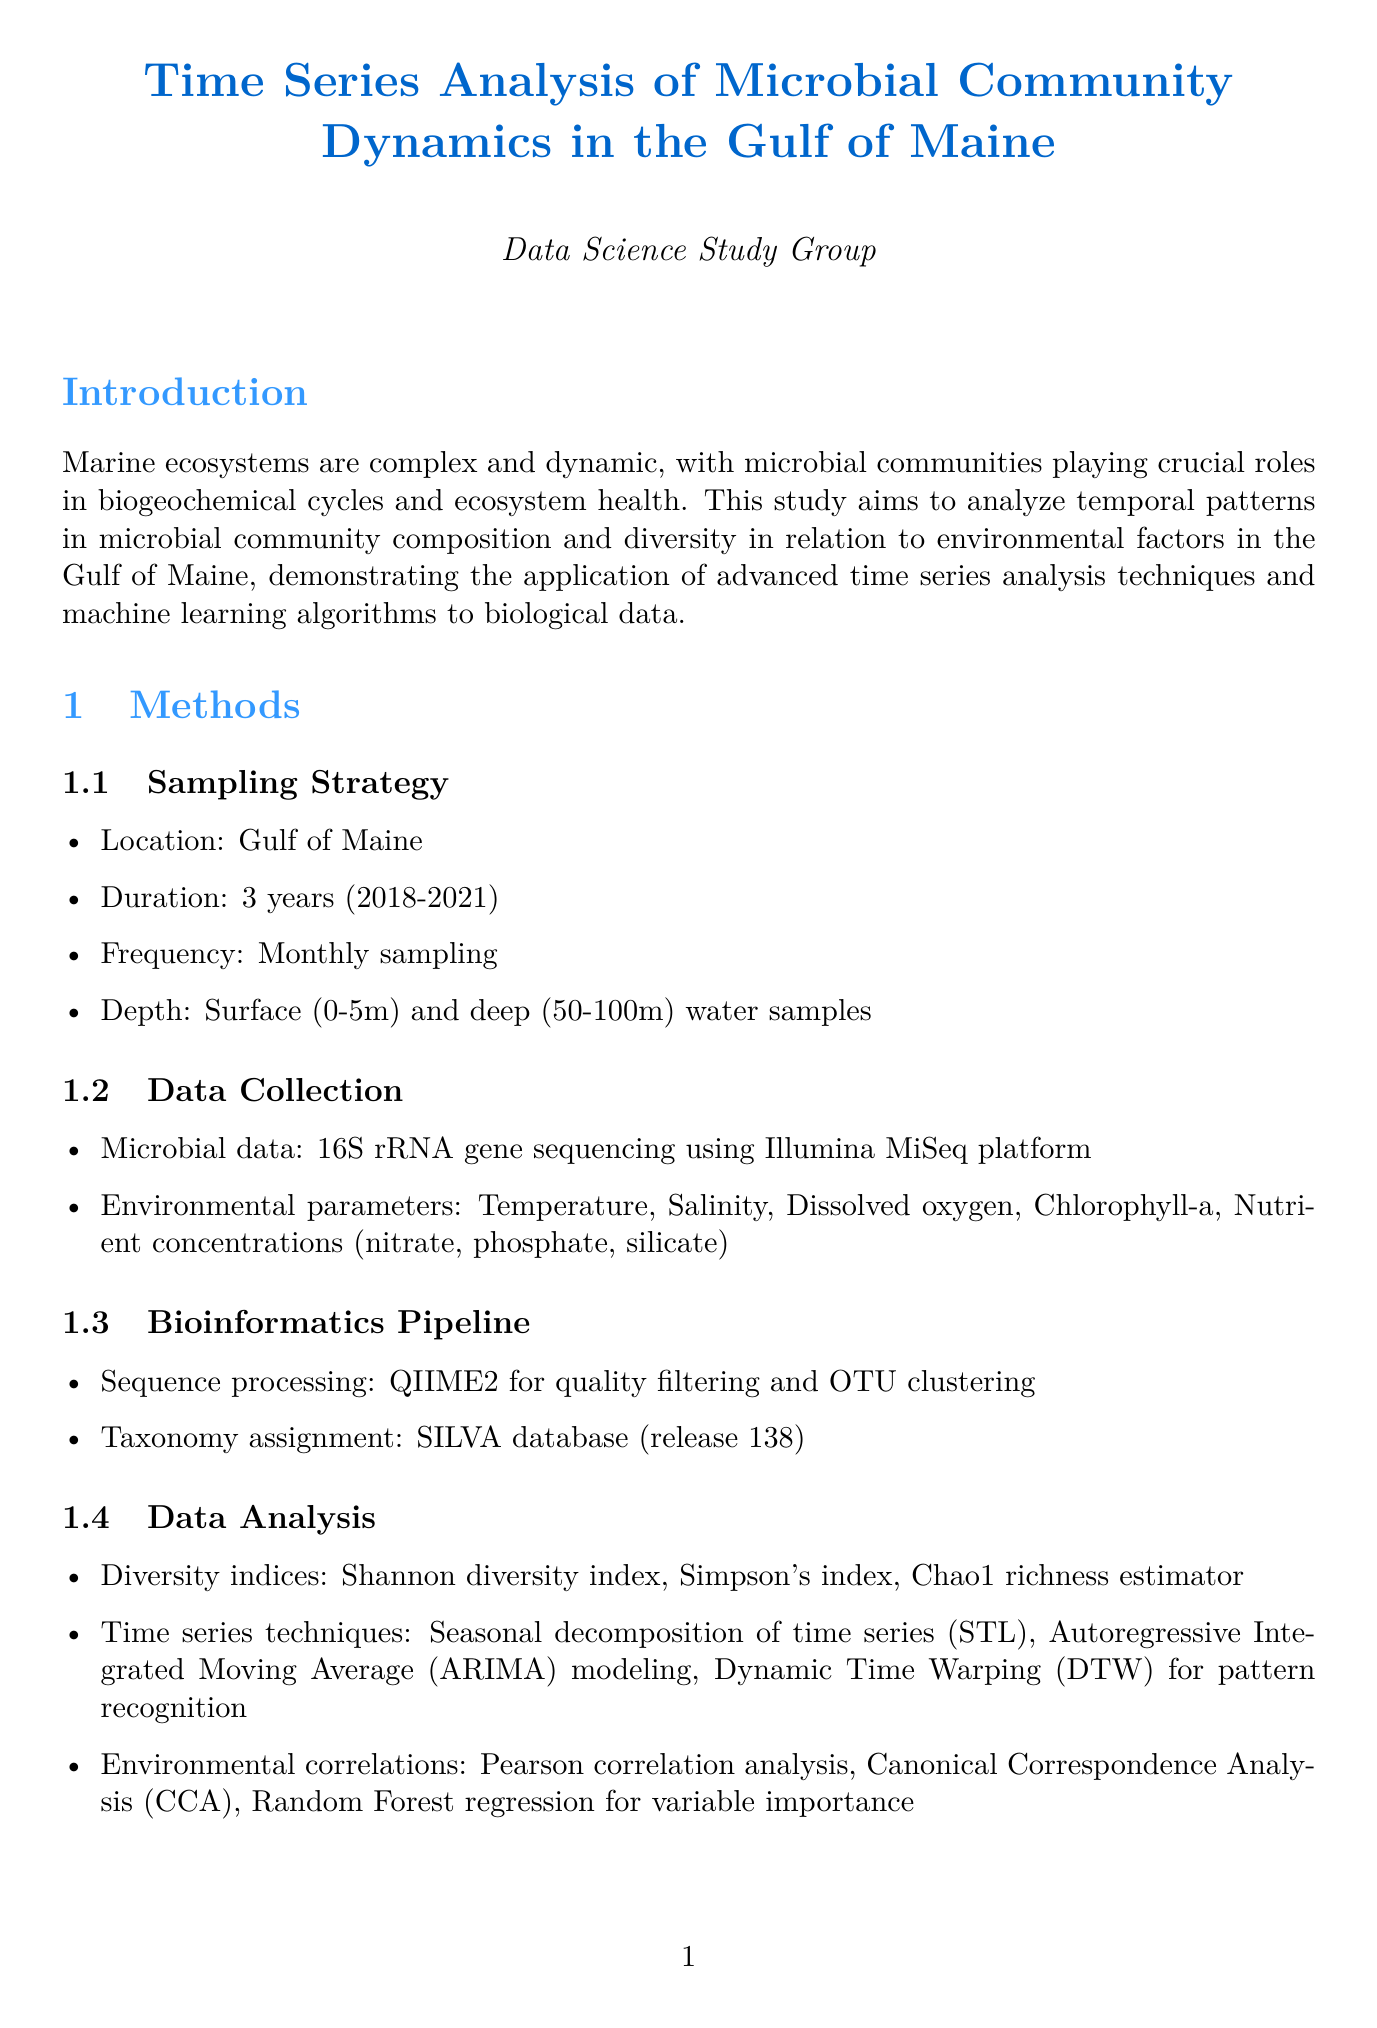What is the title of the report? The title is stated at the beginning of the document, summarizing the primary focus of the study.
Answer: Time Series Analysis of Microbial Community Dynamics in the Gulf of Maine What years did the study cover? The duration of the study is specified in the methods section, indicating the years of data collection.
Answer: 2018-2021 What sampling frequency was used? The frequency of sampling is mentioned in the sampling strategy subsection, detailing how often samples were collected.
Answer: Monthly sampling What is the strongest correlation found in the study? The environmental drivers section indicates which environmental parameter had the most significant effect on microbial community changes.
Answer: Temperature Which time series model had the best fit for predicting community composition? The time series models section summarizes the results of model performance, identifying the most effective modeling approach.
Answer: ARIMA(2,1,1) What trend was observed in microbial diversity over the study period? The diversity trends section describes the long-term changes in microbial diversity throughout the three years of study.
Answer: Slight increase in overall diversity What are the dominant phyla identified in the study? The community composition section lists the primary taxonomic groups observed in microbial samples, showcasing the community structure.
Answer: Proteobacteria, Bacteroidetes, Cyanobacteria, Actinobacteria What is one future direction suggested in the discussion? The future directions subsection provides possible next steps for research and analysis based on the findings of the study.
Answer: Incorporate metagenomic data for functional analysis What analysis method was used for variable importance? The data analysis section outlines methods utilized for examining the relationship between environmental parameters and microbial communities.
Answer: Random Forest regression 